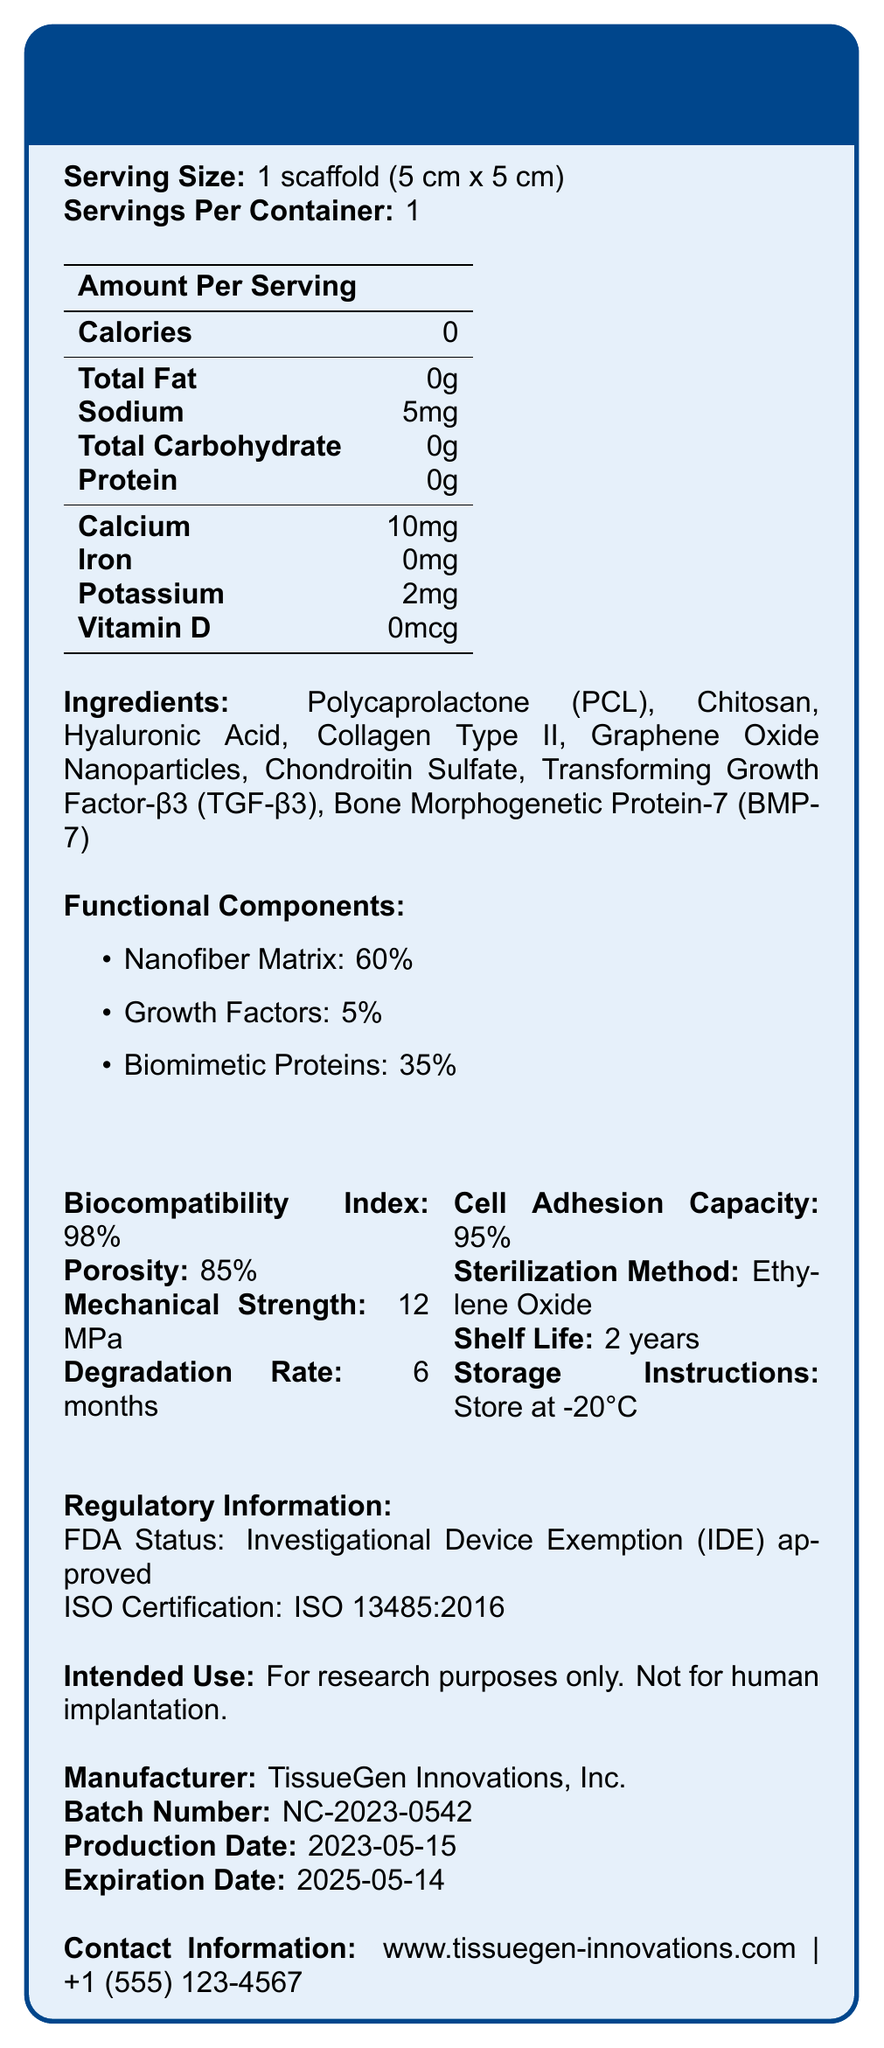What is the serving size of the NanoCart-X Scaffold? The serving size information is located at the beginning of the document under "Serving Size."
Answer: 1 scaffold (5 cm x 5 cm) What is the biocompatibility index of the NanoCart-X Scaffold? The biocompatibility index is listed under the "Biocompatibility Index" section.
Answer: 98% How many calories are in one serving of the NanoCart-X Scaffold? The amount of calories per serving is shown in the "Amount Per Serving" section of the document.
Answer: 0 What is the percentage of nanofiber matrix in the NanoCart-X Scaffold? The percentage composition of the nanofiber matrix is listed under the "Functional Components" section.
Answer: 60% Who is the manufacturer of the NanoCart-X Scaffold? The manufacturer's information is provided at the bottom of the document.
Answer: TissueGen Innovations, Inc. What is the degradation rate for the NanoCart-X Scaffold? The degradation rate can be found under the "Degradation Rate" section.
Answer: 6 months What is the storage temperature recommended for the NanoCart-X Scaffold? The storage instructions specify that the scaffold should be stored at -20°C.
Answer: -20°C What are the growth factors present in the NanoCart-X Scaffold? A. TGF-β3 and BMP-7 B. BMP-7 and Collagen Type II C. Collagen Type II and Chitosan D. TGF-β3 and Hyaluronic Acid The ingredients list includes "Transforming Growth Factor-β3 (TGF-β3)" and "Bone Morphogenetic Protein-7 (BMP-7)" indicating these two growth factors are present.
Answer: A. TGF-β3 and BMP-7 How much iron is present in the NanoCart-X Scaffold? A. 0mg B. 5mg C. 2mg D. 10mg The amount of iron per serving is specified in the "Amount Per Serving" table as 0mg.
Answer: A. 0mg Is the NanoCart-X Scaffold intended for human implantation? The document states "For research purposes only. Not for human implantation."
Answer: No Summarize the main information provided about the NanoCart-X Scaffold. The summary covers the key aspects, including composition, biocompatibility, intended use, manufacturer, and regulatory status, providing a comprehensive overview of the document.
Answer: The NanoCart-X Scaffold is a nanofiber-reinforced cartilage scaffold material designed for research purposes. It has a high biocompatibility index, substantial porosity, mechanical strength, and a shelf life of 2 years. The scaffold contains various functional components, including a nanofiber matrix, growth factors, and biomimetic proteins. It must be stored at -20°C and is not intended for human implantation. It is manufactured by TissueGen Innovations, Inc., and has specific regulatory approvals. What is the mechanical strength of the NanoCart-X Scaffold? The mechanical strength information is listed in the document under the "Mechanical Strength" section.
Answer: 12 MPa What is the FDA status of the NanoCart-X Scaffold? The FDA status is detailed in the "Regulatory Information" section.
Answer: Investigational Device Exemption (IDE) approved How many ingredients are listed in the NanoCart-X Scaffold? The ingredients list includes Polycaprolactone (PCL), Chitosan, Hyaluronic Acid, Collagen Type II, Graphene Oxide Nanoparticles, Chondroitin Sulfate, TGF-β3, and BMP-7, totaling eight ingredients.
Answer: 8 Can the NanoCart-X Scaffold be used for clinical treatments in humans? The document explicitly states that it is "For research purposes only. Not for human implantation."
Answer: No Is there any mention of the electrical conductivity of the NanoCart-X Scaffold? The document does not provide any information regarding the electrical conductivity of the scaffold.
Answer: Not enough information 